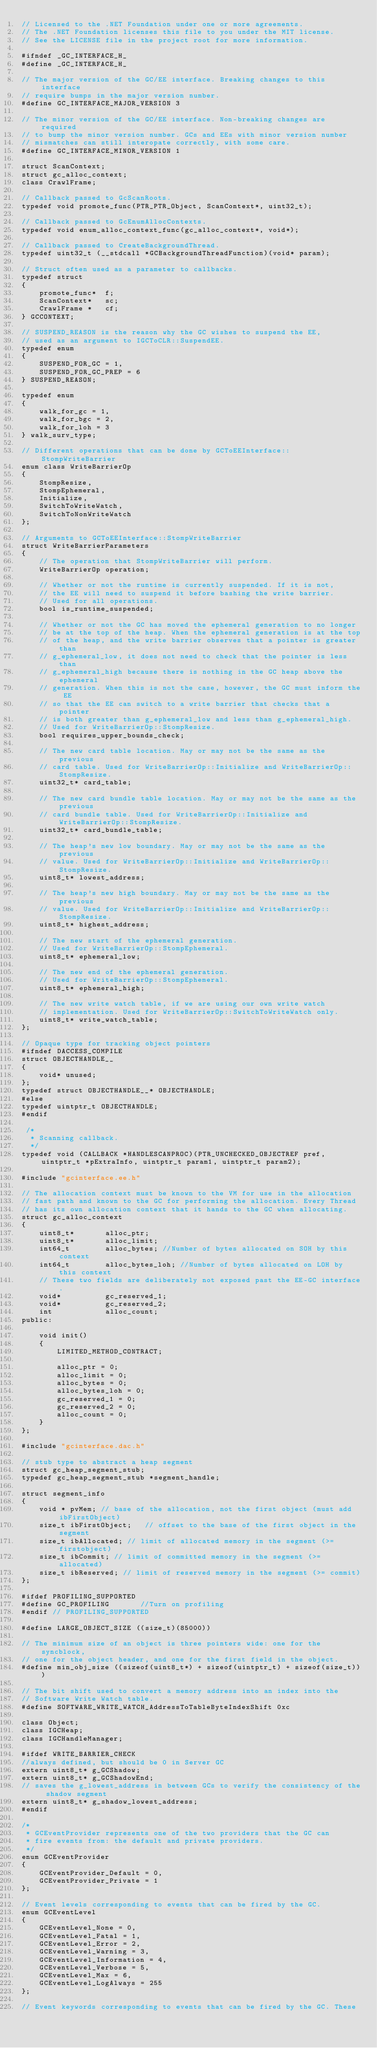Convert code to text. <code><loc_0><loc_0><loc_500><loc_500><_C_>// Licensed to the .NET Foundation under one or more agreements.
// The .NET Foundation licenses this file to you under the MIT license.
// See the LICENSE file in the project root for more information.

#ifndef _GC_INTERFACE_H_
#define _GC_INTERFACE_H_

// The major version of the GC/EE interface. Breaking changes to this interface
// require bumps in the major version number.
#define GC_INTERFACE_MAJOR_VERSION 3

// The minor version of the GC/EE interface. Non-breaking changes are required
// to bump the minor version number. GCs and EEs with minor version number
// mismatches can still interopate correctly, with some care.
#define GC_INTERFACE_MINOR_VERSION 1

struct ScanContext;
struct gc_alloc_context;
class CrawlFrame;

// Callback passed to GcScanRoots.
typedef void promote_func(PTR_PTR_Object, ScanContext*, uint32_t);

// Callback passed to GcEnumAllocContexts.
typedef void enum_alloc_context_func(gc_alloc_context*, void*);

// Callback passed to CreateBackgroundThread.
typedef uint32_t (__stdcall *GCBackgroundThreadFunction)(void* param);

// Struct often used as a parameter to callbacks.
typedef struct
{
    promote_func*  f;
    ScanContext*   sc;
    CrawlFrame *   cf;
} GCCONTEXT;

// SUSPEND_REASON is the reason why the GC wishes to suspend the EE,
// used as an argument to IGCToCLR::SuspendEE.
typedef enum
{
    SUSPEND_FOR_GC = 1,
    SUSPEND_FOR_GC_PREP = 6
} SUSPEND_REASON;

typedef enum
{
    walk_for_gc = 1,
    walk_for_bgc = 2,
    walk_for_loh = 3
} walk_surv_type;

// Different operations that can be done by GCToEEInterface::StompWriteBarrier
enum class WriteBarrierOp
{
    StompResize,
    StompEphemeral,
    Initialize,
    SwitchToWriteWatch,
    SwitchToNonWriteWatch
};

// Arguments to GCToEEInterface::StompWriteBarrier
struct WriteBarrierParameters
{
    // The operation that StompWriteBarrier will perform.
    WriteBarrierOp operation;

    // Whether or not the runtime is currently suspended. If it is not,
    // the EE will need to suspend it before bashing the write barrier.
    // Used for all operations.
    bool is_runtime_suspended;

    // Whether or not the GC has moved the ephemeral generation to no longer
    // be at the top of the heap. When the ephemeral generation is at the top
    // of the heap, and the write barrier observes that a pointer is greater than
    // g_ephemeral_low, it does not need to check that the pointer is less than
    // g_ephemeral_high because there is nothing in the GC heap above the ephemeral
    // generation. When this is not the case, however, the GC must inform the EE
    // so that the EE can switch to a write barrier that checks that a pointer
    // is both greater than g_ephemeral_low and less than g_ephemeral_high.
    // Used for WriteBarrierOp::StompResize.
    bool requires_upper_bounds_check;

    // The new card table location. May or may not be the same as the previous
    // card table. Used for WriteBarrierOp::Initialize and WriteBarrierOp::StompResize.
    uint32_t* card_table;

    // The new card bundle table location. May or may not be the same as the previous
    // card bundle table. Used for WriteBarrierOp::Initialize and WriteBarrierOp::StompResize.
    uint32_t* card_bundle_table;

    // The heap's new low boundary. May or may not be the same as the previous
    // value. Used for WriteBarrierOp::Initialize and WriteBarrierOp::StompResize.
    uint8_t* lowest_address;

    // The heap's new high boundary. May or may not be the same as the previous
    // value. Used for WriteBarrierOp::Initialize and WriteBarrierOp::StompResize.
    uint8_t* highest_address;

    // The new start of the ephemeral generation. 
    // Used for WriteBarrierOp::StompEphemeral.
    uint8_t* ephemeral_low;

    // The new end of the ephemeral generation.
    // Used for WriteBarrierOp::StompEphemeral.
    uint8_t* ephemeral_high;

    // The new write watch table, if we are using our own write watch
    // implementation. Used for WriteBarrierOp::SwitchToWriteWatch only.
    uint8_t* write_watch_table;
};

// Opaque type for tracking object pointers
#ifndef DACCESS_COMPILE
struct OBJECTHANDLE__
{
    void* unused;
};
typedef struct OBJECTHANDLE__* OBJECTHANDLE;
#else
typedef uintptr_t OBJECTHANDLE;
#endif

 /*
  * Scanning callback.
  */
typedef void (CALLBACK *HANDLESCANPROC)(PTR_UNCHECKED_OBJECTREF pref, uintptr_t *pExtraInfo, uintptr_t param1, uintptr_t param2);

#include "gcinterface.ee.h"

// The allocation context must be known to the VM for use in the allocation
// fast path and known to the GC for performing the allocation. Every Thread
// has its own allocation context that it hands to the GC when allocating.
struct gc_alloc_context
{
    uint8_t*       alloc_ptr;
    uint8_t*       alloc_limit;
    int64_t        alloc_bytes; //Number of bytes allocated on SOH by this context
    int64_t        alloc_bytes_loh; //Number of bytes allocated on LOH by this context
    // These two fields are deliberately not exposed past the EE-GC interface.
    void*          gc_reserved_1;
    void*          gc_reserved_2;
    int            alloc_count;
public:

    void init()
    {
        LIMITED_METHOD_CONTRACT;

        alloc_ptr = 0;
        alloc_limit = 0;
        alloc_bytes = 0;
        alloc_bytes_loh = 0;
        gc_reserved_1 = 0;
        gc_reserved_2 = 0;
        alloc_count = 0;
    }
};

#include "gcinterface.dac.h"

// stub type to abstract a heap segment
struct gc_heap_segment_stub;
typedef gc_heap_segment_stub *segment_handle;

struct segment_info
{
    void * pvMem; // base of the allocation, not the first object (must add ibFirstObject)
    size_t ibFirstObject;   // offset to the base of the first object in the segment
    size_t ibAllocated; // limit of allocated memory in the segment (>= firstobject)
    size_t ibCommit; // limit of committed memory in the segment (>= allocated)
    size_t ibReserved; // limit of reserved memory in the segment (>= commit)
};

#ifdef PROFILING_SUPPORTED
#define GC_PROFILING       //Turn on profiling
#endif // PROFILING_SUPPORTED

#define LARGE_OBJECT_SIZE ((size_t)(85000))

// The minimum size of an object is three pointers wide: one for the syncblock,
// one for the object header, and one for the first field in the object.
#define min_obj_size ((sizeof(uint8_t*) + sizeof(uintptr_t) + sizeof(size_t)))

// The bit shift used to convert a memory address into an index into the
// Software Write Watch table.
#define SOFTWARE_WRITE_WATCH_AddressToTableByteIndexShift 0xc

class Object;
class IGCHeap;
class IGCHandleManager;

#ifdef WRITE_BARRIER_CHECK
//always defined, but should be 0 in Server GC
extern uint8_t* g_GCShadow;
extern uint8_t* g_GCShadowEnd;
// saves the g_lowest_address in between GCs to verify the consistency of the shadow segment
extern uint8_t* g_shadow_lowest_address;
#endif

/*
 * GCEventProvider represents one of the two providers that the GC can
 * fire events from: the default and private providers.
 */
enum GCEventProvider
{
    GCEventProvider_Default = 0,
    GCEventProvider_Private = 1
};

// Event levels corresponding to events that can be fired by the GC.
enum GCEventLevel
{
    GCEventLevel_None = 0,
    GCEventLevel_Fatal = 1,
    GCEventLevel_Error = 2,
    GCEventLevel_Warning = 3,
    GCEventLevel_Information = 4,
    GCEventLevel_Verbose = 5,
    GCEventLevel_Max = 6,
    GCEventLevel_LogAlways = 255
};

// Event keywords corresponding to events that can be fired by the GC. These</code> 